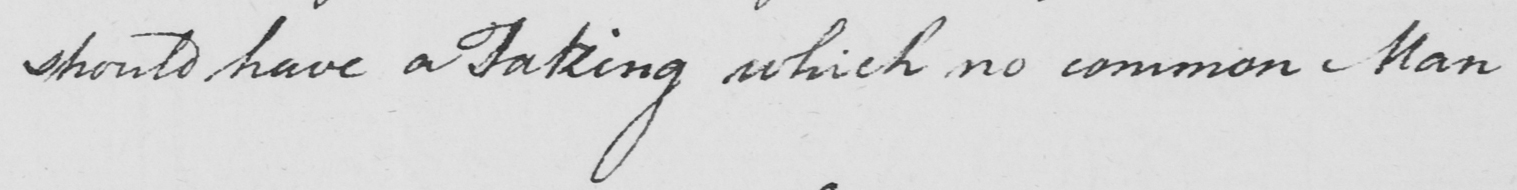Can you tell me what this handwritten text says? should have a taking which no common Man 